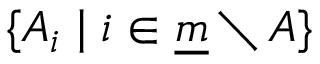Convert formula to latex. <formula><loc_0><loc_0><loc_500><loc_500>\{ A _ { i } | i \in { \underline { m } } \ A \}</formula> 